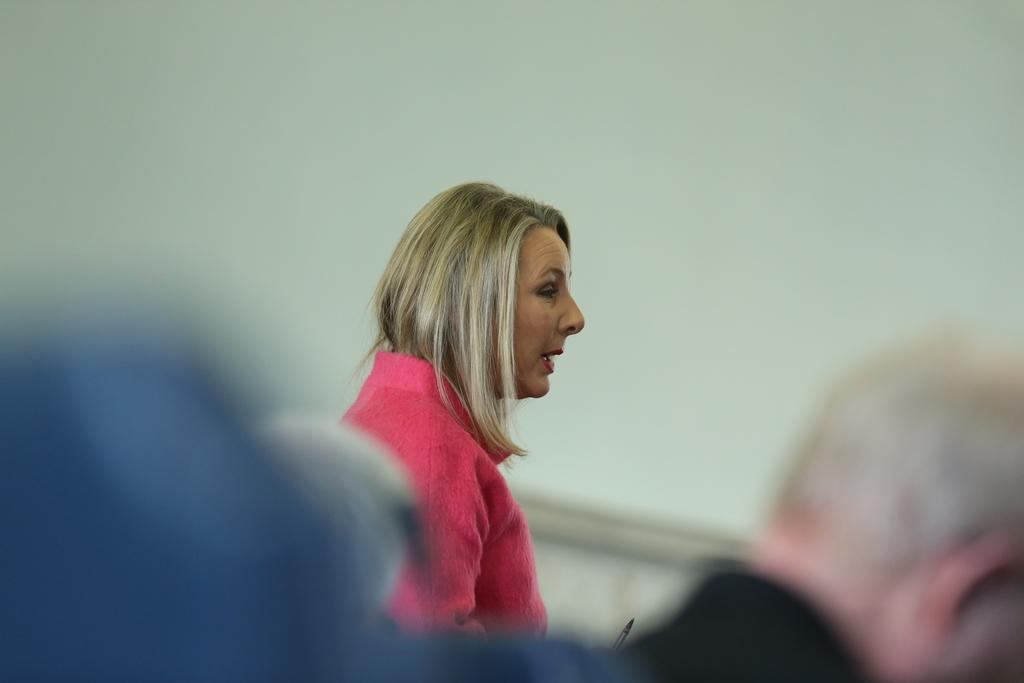Describe this image in one or two sentences. In this picture we can see there are two people and behind the people there is a wall. 